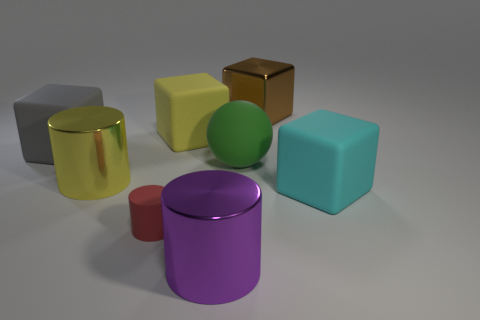Add 2 large gray rubber blocks. How many objects exist? 10 Subtract all spheres. How many objects are left? 7 Add 1 big metal cylinders. How many big metal cylinders are left? 3 Add 6 small blue rubber cubes. How many small blue rubber cubes exist? 6 Subtract 1 purple cylinders. How many objects are left? 7 Subtract all large cubes. Subtract all big rubber blocks. How many objects are left? 1 